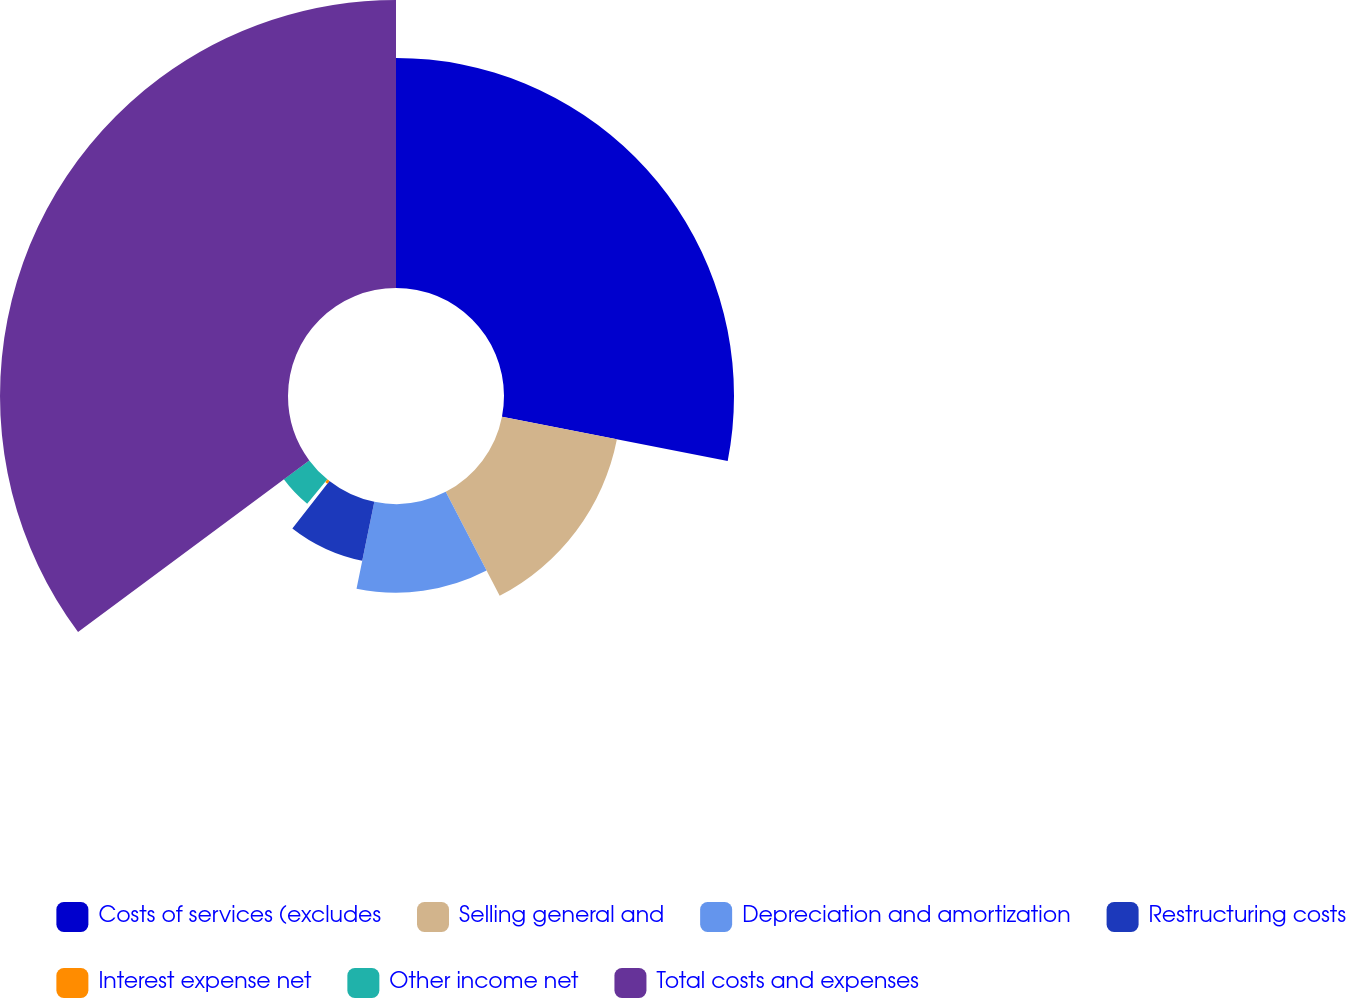Convert chart to OTSL. <chart><loc_0><loc_0><loc_500><loc_500><pie_chart><fcel>Costs of services (excludes<fcel>Selling general and<fcel>Depreciation and amortization<fcel>Restructuring costs<fcel>Interest expense net<fcel>Other income net<fcel>Total costs and expenses<nl><fcel>28.08%<fcel>14.3%<fcel>10.83%<fcel>7.35%<fcel>0.4%<fcel>3.87%<fcel>35.16%<nl></chart> 